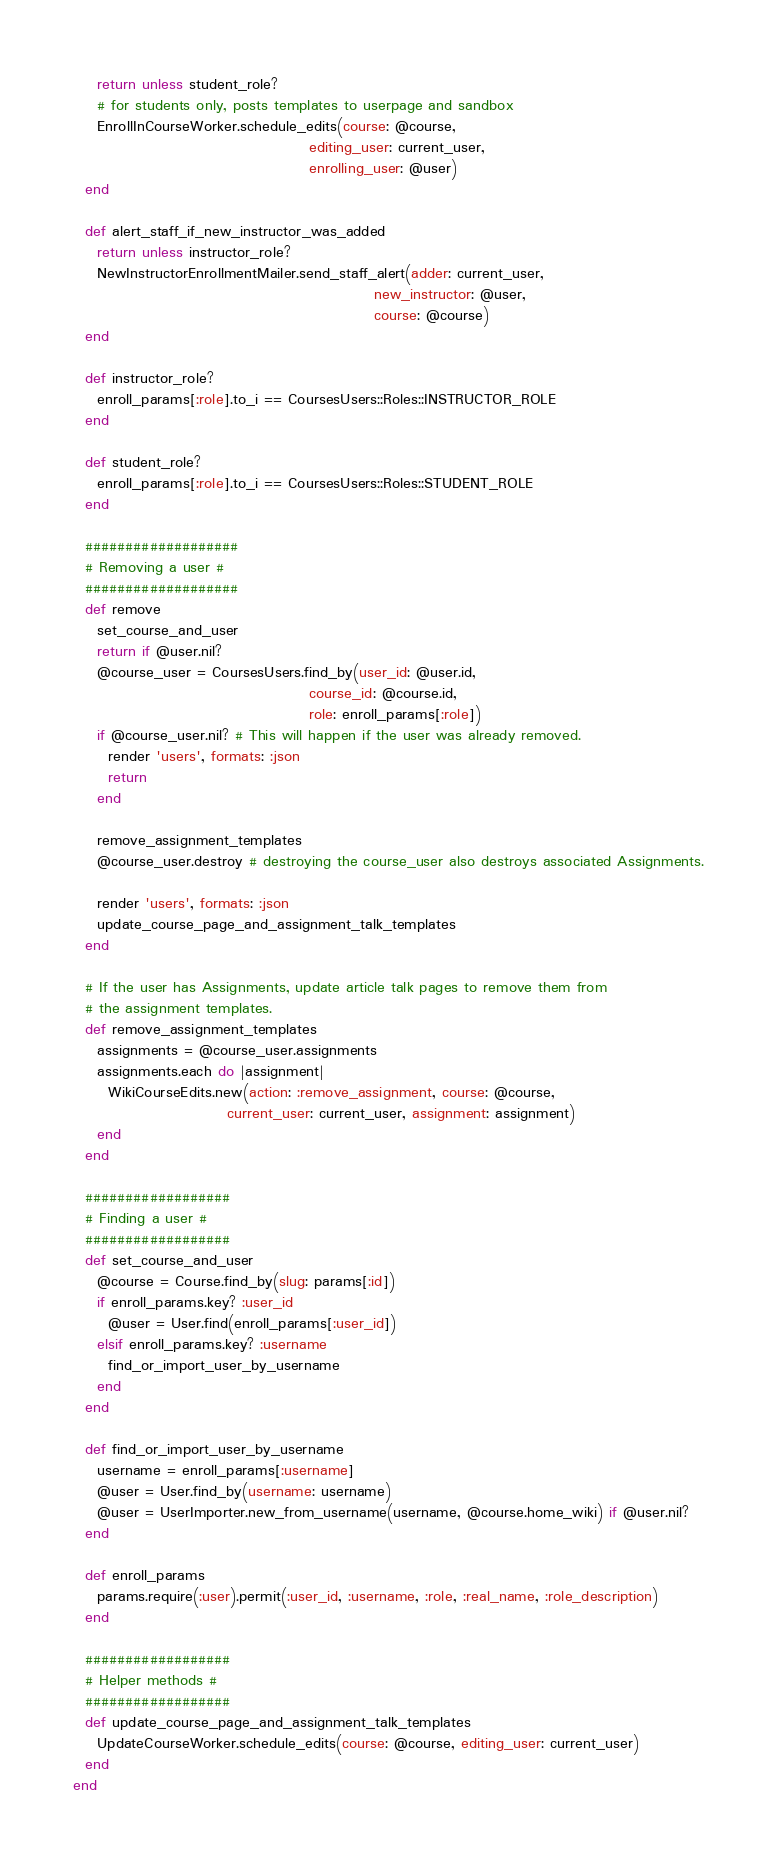Convert code to text. <code><loc_0><loc_0><loc_500><loc_500><_Ruby_>    return unless student_role?
    # for students only, posts templates to userpage and sandbox
    EnrollInCourseWorker.schedule_edits(course: @course,
                                        editing_user: current_user,
                                        enrolling_user: @user)
  end

  def alert_staff_if_new_instructor_was_added
    return unless instructor_role?
    NewInstructorEnrollmentMailer.send_staff_alert(adder: current_user,
                                                   new_instructor: @user,
                                                   course: @course)
  end

  def instructor_role?
    enroll_params[:role].to_i == CoursesUsers::Roles::INSTRUCTOR_ROLE
  end

  def student_role?
    enroll_params[:role].to_i == CoursesUsers::Roles::STUDENT_ROLE
  end

  ###################
  # Removing a user #
  ###################
  def remove
    set_course_and_user
    return if @user.nil?
    @course_user = CoursesUsers.find_by(user_id: @user.id,
                                        course_id: @course.id,
                                        role: enroll_params[:role])
    if @course_user.nil? # This will happen if the user was already removed.
      render 'users', formats: :json
      return
    end

    remove_assignment_templates
    @course_user.destroy # destroying the course_user also destroys associated Assignments.

    render 'users', formats: :json
    update_course_page_and_assignment_talk_templates
  end

  # If the user has Assignments, update article talk pages to remove them from
  # the assignment templates.
  def remove_assignment_templates
    assignments = @course_user.assignments
    assignments.each do |assignment|
      WikiCourseEdits.new(action: :remove_assignment, course: @course,
                          current_user: current_user, assignment: assignment)
    end
  end

  ##################
  # Finding a user #
  ##################
  def set_course_and_user
    @course = Course.find_by(slug: params[:id])
    if enroll_params.key? :user_id
      @user = User.find(enroll_params[:user_id])
    elsif enroll_params.key? :username
      find_or_import_user_by_username
    end
  end

  def find_or_import_user_by_username
    username = enroll_params[:username]
    @user = User.find_by(username: username)
    @user = UserImporter.new_from_username(username, @course.home_wiki) if @user.nil?
  end

  def enroll_params
    params.require(:user).permit(:user_id, :username, :role, :real_name, :role_description)
  end

  ##################
  # Helper methods #
  ##################
  def update_course_page_and_assignment_talk_templates
    UpdateCourseWorker.schedule_edits(course: @course, editing_user: current_user)
  end
end
</code> 